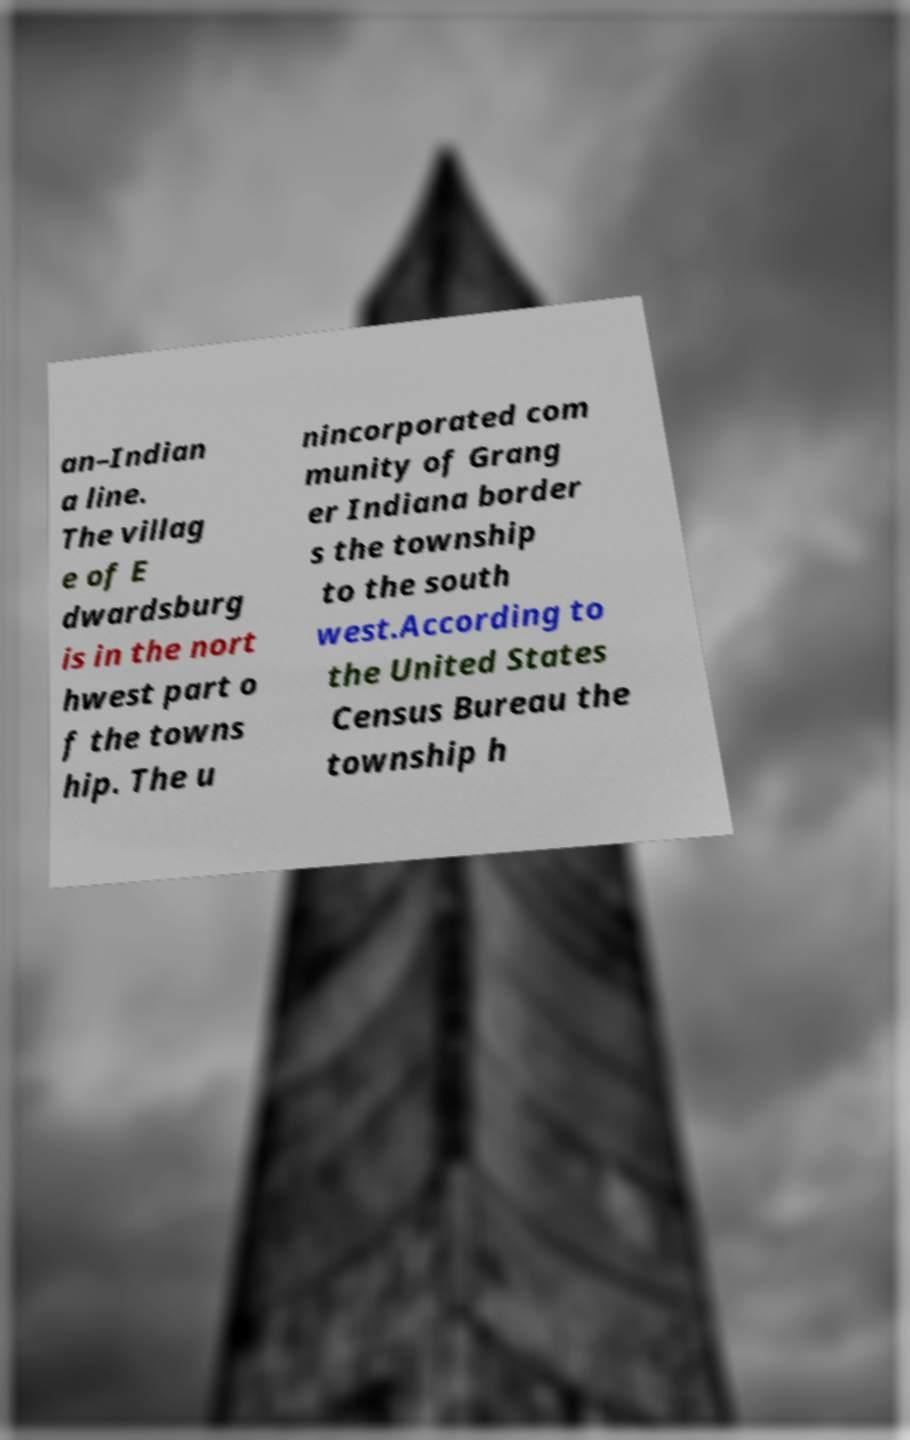What messages or text are displayed in this image? I need them in a readable, typed format. an–Indian a line. The villag e of E dwardsburg is in the nort hwest part o f the towns hip. The u nincorporated com munity of Grang er Indiana border s the township to the south west.According to the United States Census Bureau the township h 